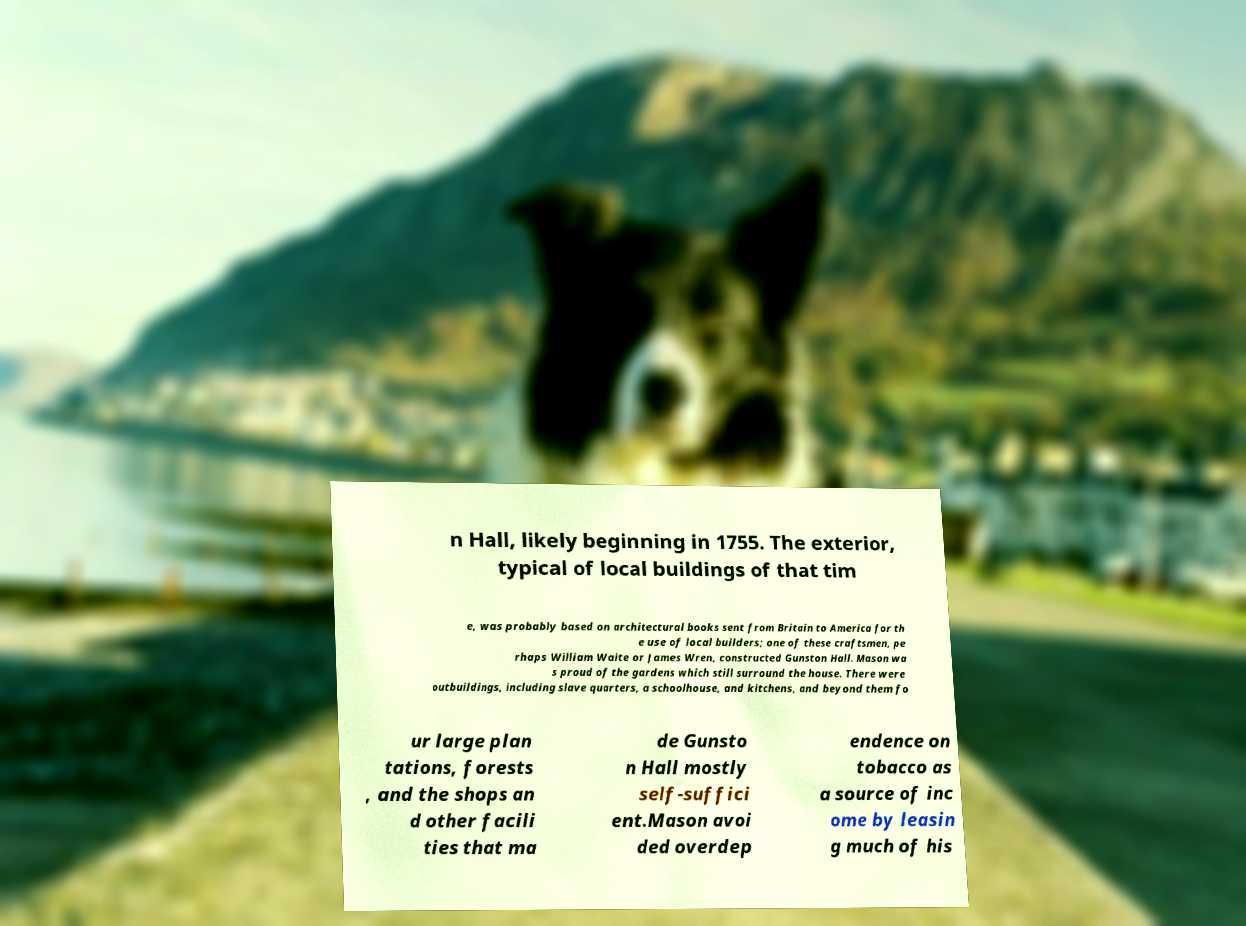I need the written content from this picture converted into text. Can you do that? n Hall, likely beginning in 1755. The exterior, typical of local buildings of that tim e, was probably based on architectural books sent from Britain to America for th e use of local builders; one of these craftsmen, pe rhaps William Waite or James Wren, constructed Gunston Hall. Mason wa s proud of the gardens which still surround the house. There were outbuildings, including slave quarters, a schoolhouse, and kitchens, and beyond them fo ur large plan tations, forests , and the shops an d other facili ties that ma de Gunsto n Hall mostly self-suffici ent.Mason avoi ded overdep endence on tobacco as a source of inc ome by leasin g much of his 